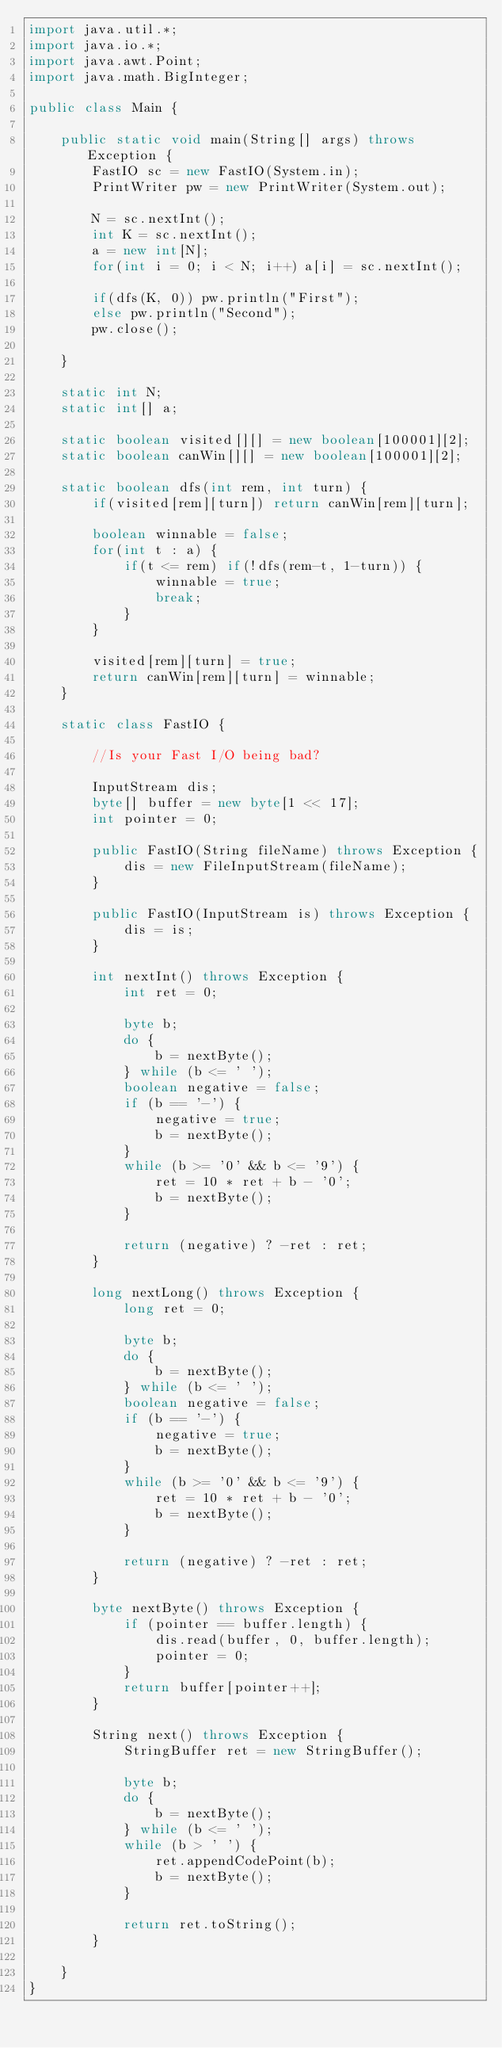Convert code to text. <code><loc_0><loc_0><loc_500><loc_500><_Java_>import java.util.*;
import java.io.*;
import java.awt.Point;
import java.math.BigInteger;

public class Main {

	public static void main(String[] args) throws Exception {
		FastIO sc = new FastIO(System.in);
		PrintWriter pw = new PrintWriter(System.out);
		
		N = sc.nextInt();
		int K = sc.nextInt();
		a = new int[N];
		for(int i = 0; i < N; i++) a[i] = sc.nextInt();
		
		if(dfs(K, 0)) pw.println("First");
		else pw.println("Second");
		pw.close();
		
	}
	
	static int N;
	static int[] a;
	
	static boolean visited[][] = new boolean[100001][2];
	static boolean canWin[][] = new boolean[100001][2];
	
	static boolean dfs(int rem, int turn) {
		if(visited[rem][turn]) return canWin[rem][turn];
		
		boolean winnable = false;
		for(int t : a) {
			if(t <= rem) if(!dfs(rem-t, 1-turn)) {
				winnable = true;
				break;
			}
		}
		
		visited[rem][turn] = true;
		return canWin[rem][turn] = winnable;
	}

	static class FastIO {

		//Is your Fast I/O being bad?

		InputStream dis;
		byte[] buffer = new byte[1 << 17];
		int pointer = 0;

		public FastIO(String fileName) throws Exception {
			dis = new FileInputStream(fileName);
		}

		public FastIO(InputStream is) throws Exception {
			dis = is;
		}

		int nextInt() throws Exception {
			int ret = 0;

			byte b;
			do {
				b = nextByte();
			} while (b <= ' ');
			boolean negative = false;
			if (b == '-') {
				negative = true;
				b = nextByte();
			}
			while (b >= '0' && b <= '9') {
				ret = 10 * ret + b - '0';
				b = nextByte();
			}

			return (negative) ? -ret : ret;
		}

		long nextLong() throws Exception {
			long ret = 0;

			byte b;
			do {
				b = nextByte();
			} while (b <= ' ');
			boolean negative = false;
			if (b == '-') {
				negative = true;
				b = nextByte();
			}
			while (b >= '0' && b <= '9') {
				ret = 10 * ret + b - '0';
				b = nextByte();
			}

			return (negative) ? -ret : ret;
		}

		byte nextByte() throws Exception {
			if (pointer == buffer.length) {
				dis.read(buffer, 0, buffer.length);
				pointer = 0;
			}
			return buffer[pointer++];
		}

		String next() throws Exception {
			StringBuffer ret = new StringBuffer();

			byte b;
			do {
				b = nextByte();
			} while (b <= ' ');
			while (b > ' ') {
				ret.appendCodePoint(b);
				b = nextByte();
			}

			return ret.toString();
		}

	}
}
</code> 